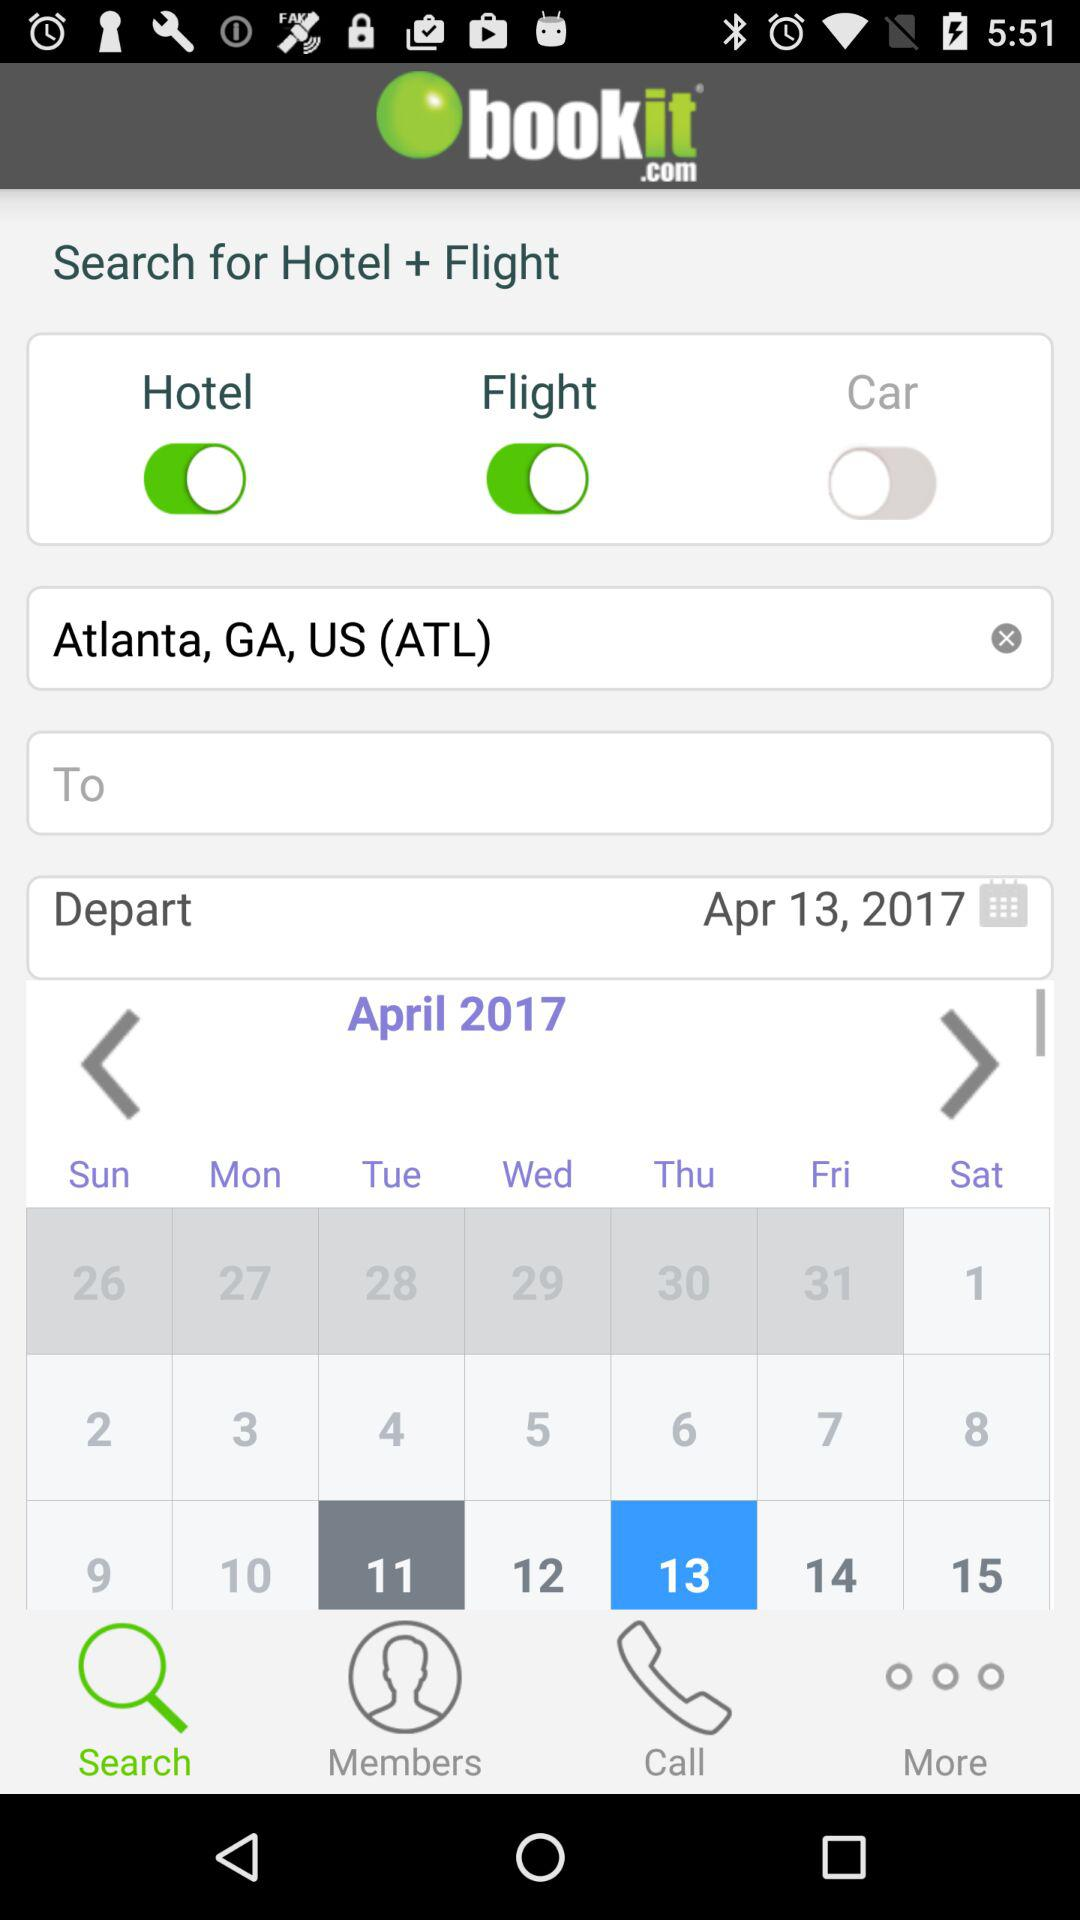From where are we searching for a flight? You are searching for a flight from "bookit.com". 